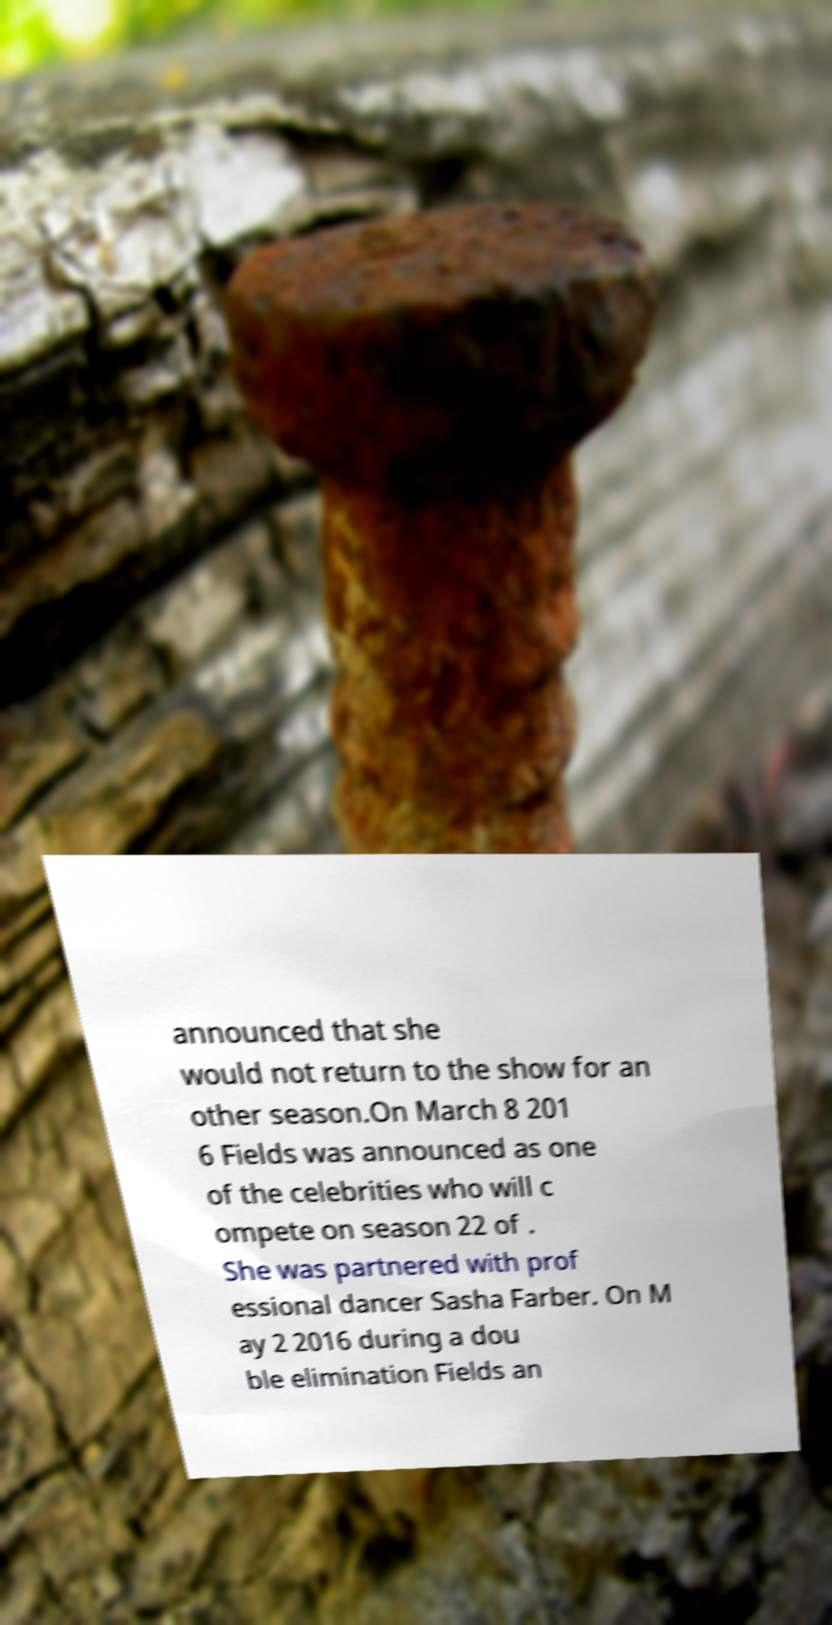What messages or text are displayed in this image? I need them in a readable, typed format. announced that she would not return to the show for an other season.On March 8 201 6 Fields was announced as one of the celebrities who will c ompete on season 22 of . She was partnered with prof essional dancer Sasha Farber. On M ay 2 2016 during a dou ble elimination Fields an 